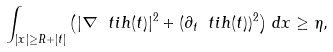Convert formula to latex. <formula><loc_0><loc_0><loc_500><loc_500>\int _ { | x | \geq R + | t | } \left ( | \nabla \ t i h ( t ) | ^ { 2 } + ( \partial _ { t } \ t i h ( t ) ) ^ { 2 } \right ) \, d x \geq \eta ,</formula> 